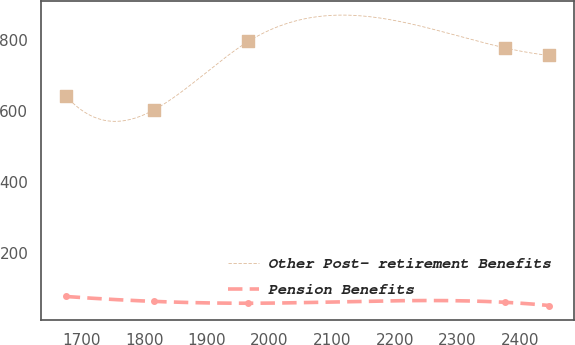<chart> <loc_0><loc_0><loc_500><loc_500><line_chart><ecel><fcel>Other Post- retirement Benefits<fcel>Pension Benefits<nl><fcel>1674.11<fcel>643.34<fcel>75.72<nl><fcel>1815.23<fcel>603.16<fcel>61.81<nl><fcel>1966.2<fcel>796.96<fcel>56.57<nl><fcel>2376.41<fcel>778.46<fcel>59.24<nl><fcel>2447.34<fcel>757.18<fcel>50.06<nl></chart> 